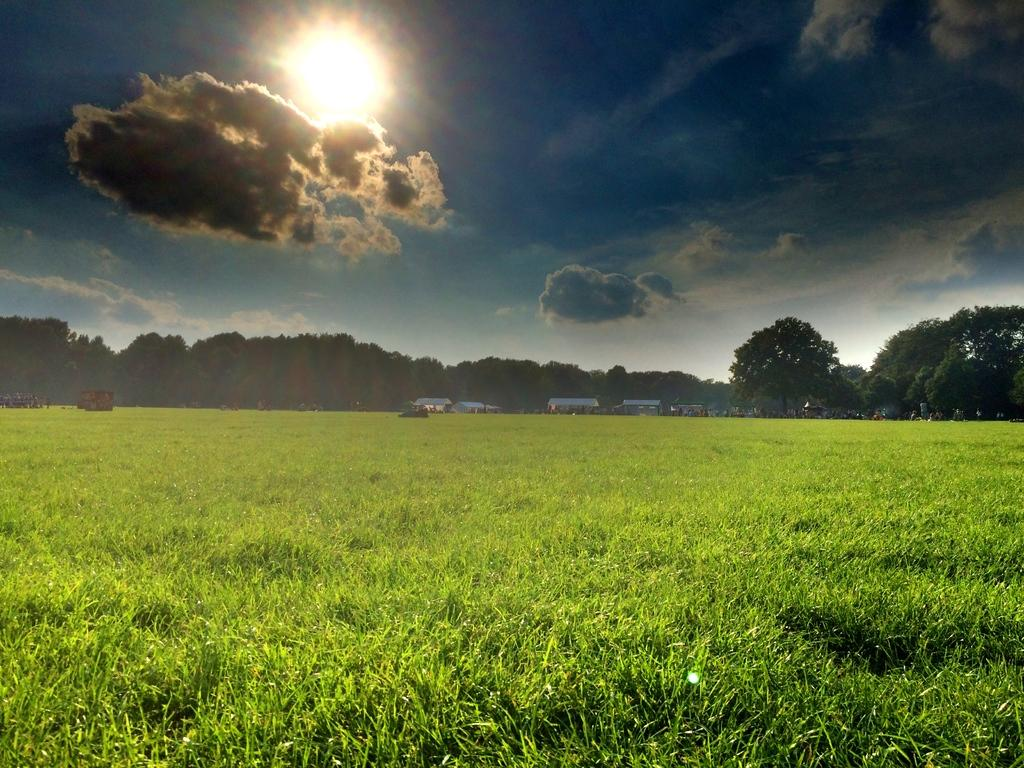What type of landscape is visible in the foreground of the image? There is a grassland in the foreground of the image. What structures can be seen in the background of the image? There are buildings in the background of the image. What else can be seen in the background of the image besides buildings? There are vehicles and trees in the background of the image. How would you describe the sky in the image? The sky is cloudy in the image. What type of drug is being transported in the carriage in the image? There is no carriage or drug present in the image. Is there a chain visible in the image? There is no chain visible in the image. 